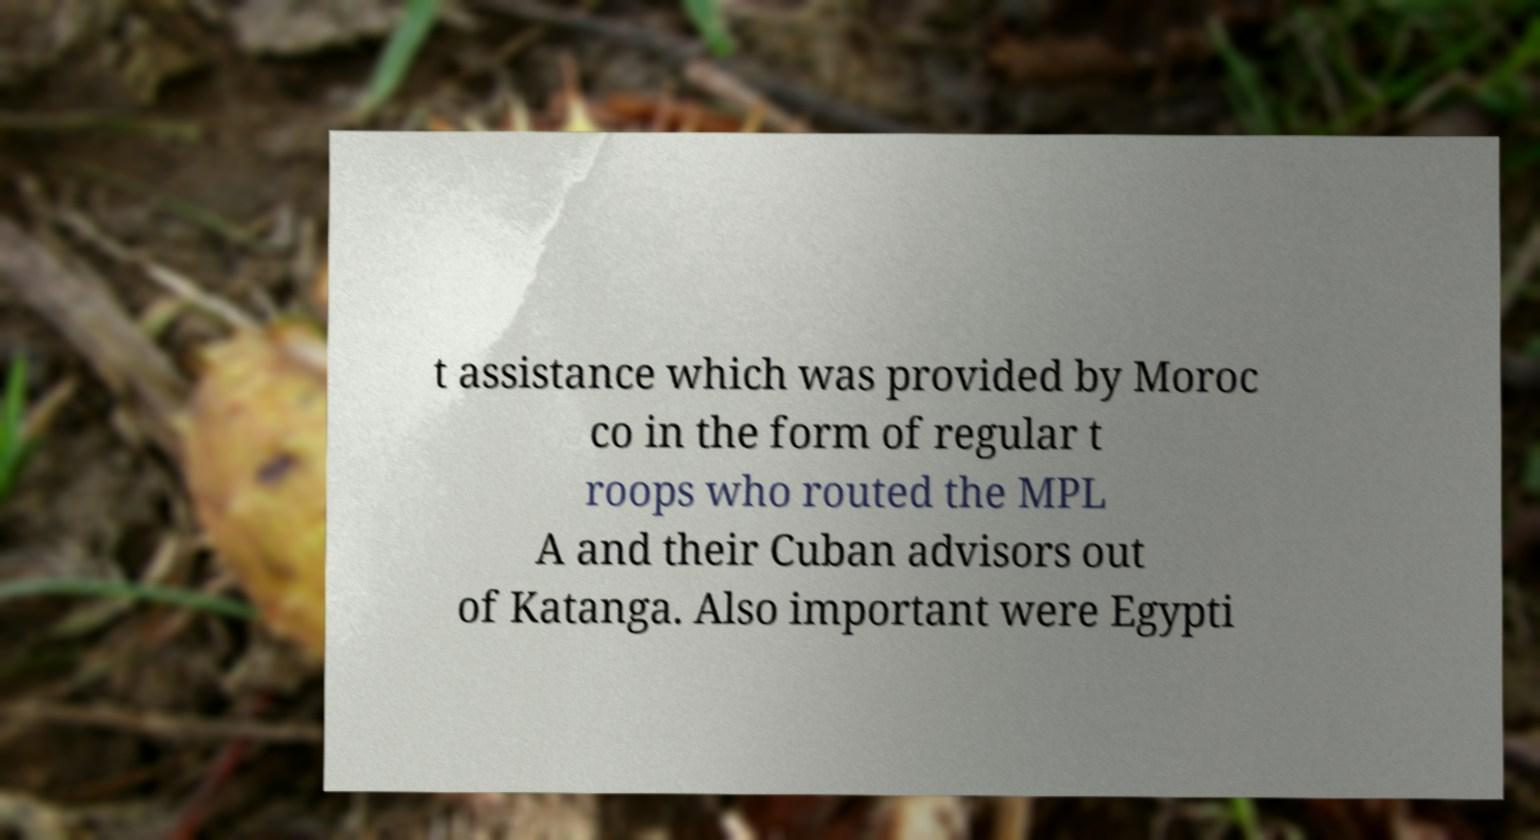For documentation purposes, I need the text within this image transcribed. Could you provide that? t assistance which was provided by Moroc co in the form of regular t roops who routed the MPL A and their Cuban advisors out of Katanga. Also important were Egypti 